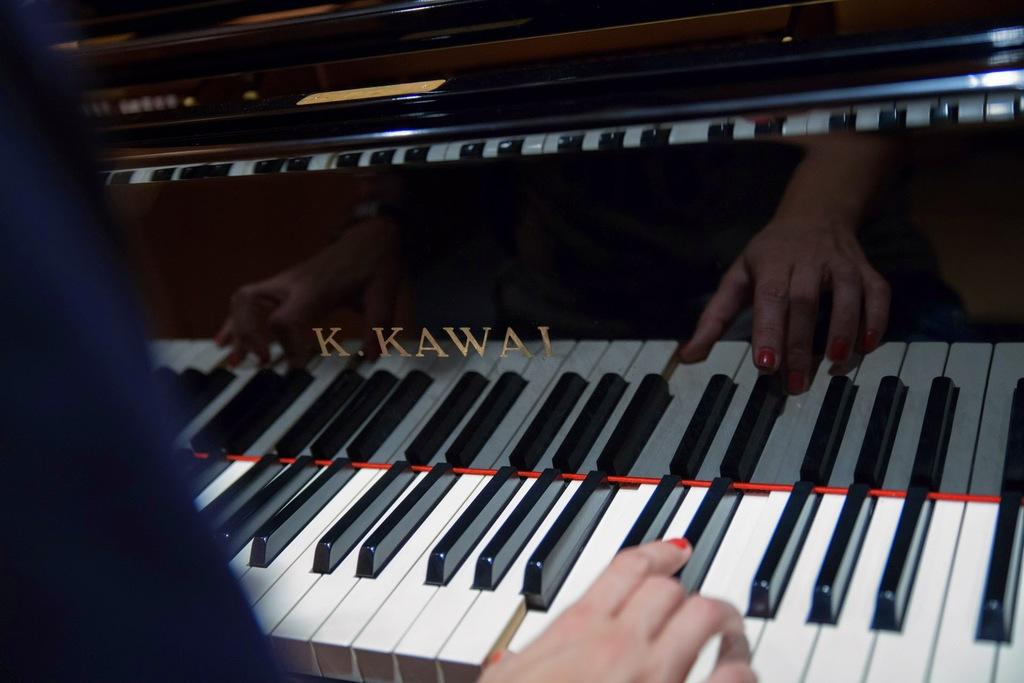What is the person on the left side of the image doing? The person is playing a piano on the left side of the image. What instrument is visible in the middle of the image? There is a piano in the middle of the image. What type of badge can be seen on the piano in the image? There is no badge present on the piano in the image. Is there a fire visible in the image? No, there is no fire visible in the image. 